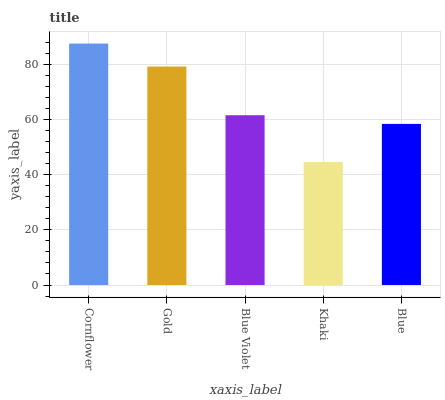Is Khaki the minimum?
Answer yes or no. Yes. Is Cornflower the maximum?
Answer yes or no. Yes. Is Gold the minimum?
Answer yes or no. No. Is Gold the maximum?
Answer yes or no. No. Is Cornflower greater than Gold?
Answer yes or no. Yes. Is Gold less than Cornflower?
Answer yes or no. Yes. Is Gold greater than Cornflower?
Answer yes or no. No. Is Cornflower less than Gold?
Answer yes or no. No. Is Blue Violet the high median?
Answer yes or no. Yes. Is Blue Violet the low median?
Answer yes or no. Yes. Is Cornflower the high median?
Answer yes or no. No. Is Cornflower the low median?
Answer yes or no. No. 